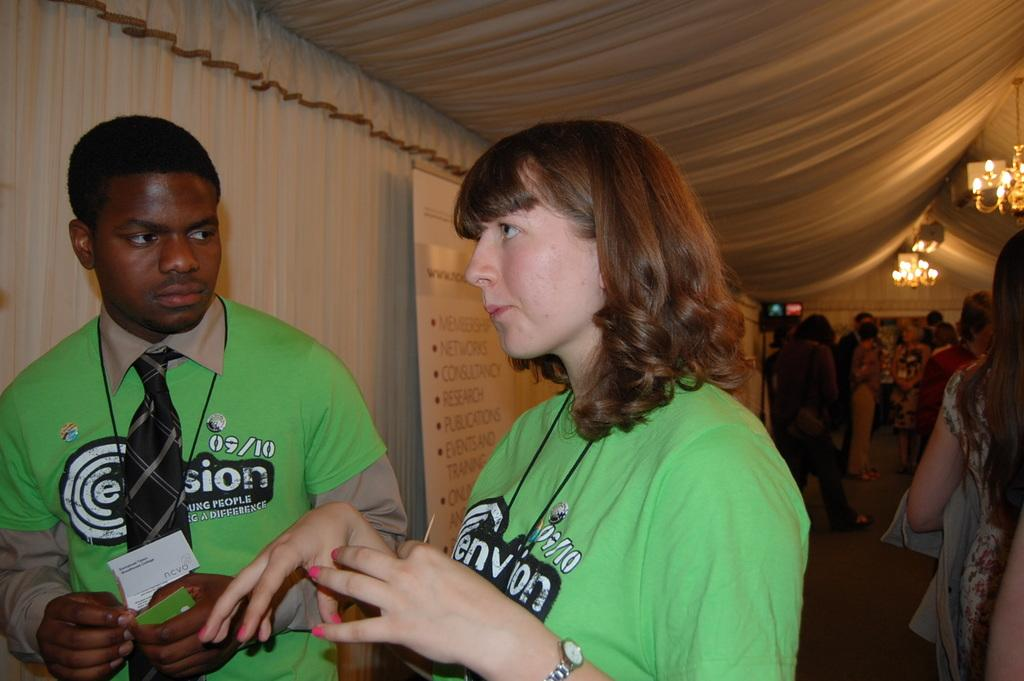Who or what can be seen in the image? There are people in the image. What is the surface that the people are standing on? The ground is visible in the image. What type of material is present in the image? There is cloth present in the image. What is attached to the roof in the image? There are lights attached to the roof in the image. What color are some of the objects in the image? There are black colored objects in the image. What type of straw is being used for the health trip in the image? There is no straw or health trip present in the image. 